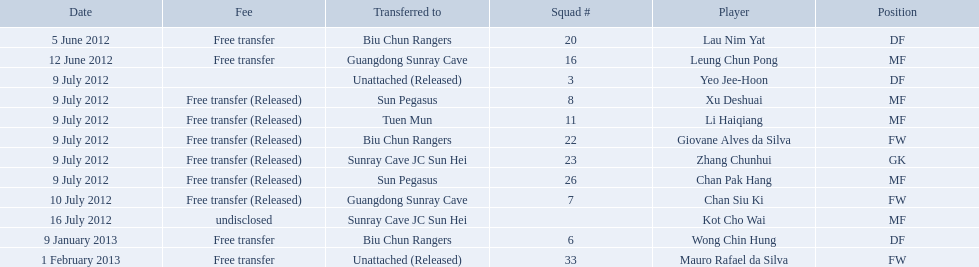Which players played during the 2012-13 south china aa season? Lau Nim Yat, Leung Chun Pong, Yeo Jee-Hoon, Xu Deshuai, Li Haiqiang, Giovane Alves da Silva, Zhang Chunhui, Chan Pak Hang, Chan Siu Ki, Kot Cho Wai, Wong Chin Hung, Mauro Rafael da Silva. Of these, which were free transfers that were not released? Lau Nim Yat, Leung Chun Pong, Wong Chin Hung, Mauro Rafael da Silva. Of these, which were in squad # 6? Wong Chin Hung. What was the date of his transfer? 9 January 2013. 